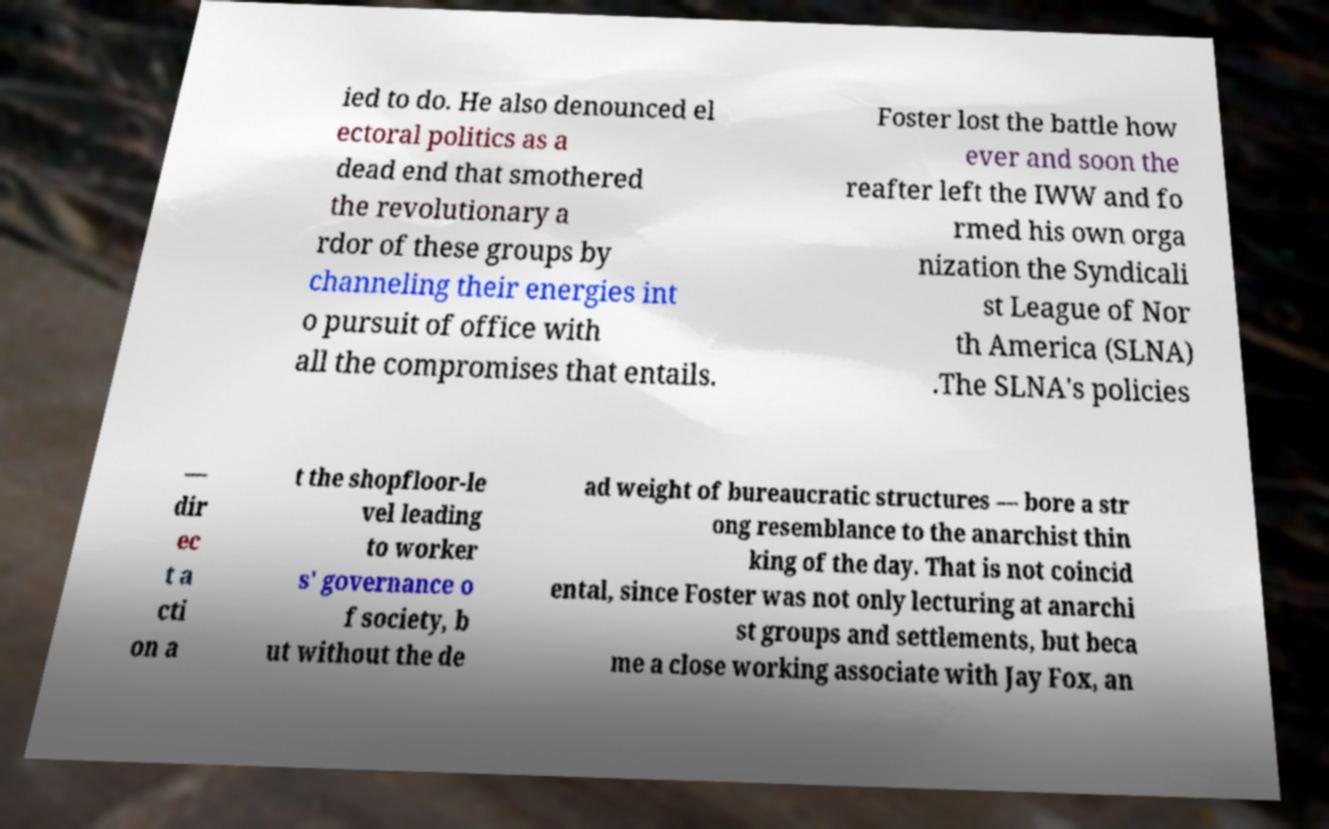Could you assist in decoding the text presented in this image and type it out clearly? ied to do. He also denounced el ectoral politics as a dead end that smothered the revolutionary a rdor of these groups by channeling their energies int o pursuit of office with all the compromises that entails. Foster lost the battle how ever and soon the reafter left the IWW and fo rmed his own orga nization the Syndicali st League of Nor th America (SLNA) .The SLNA's policies — dir ec t a cti on a t the shopfloor-le vel leading to worker s' governance o f society, b ut without the de ad weight of bureaucratic structures — bore a str ong resemblance to the anarchist thin king of the day. That is not coincid ental, since Foster was not only lecturing at anarchi st groups and settlements, but beca me a close working associate with Jay Fox, an 